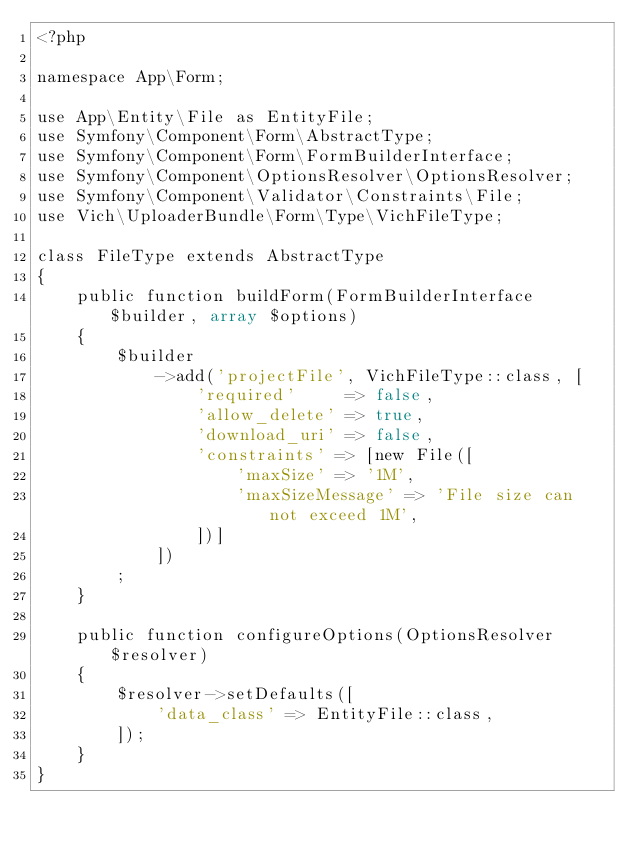Convert code to text. <code><loc_0><loc_0><loc_500><loc_500><_PHP_><?php

namespace App\Form;

use App\Entity\File as EntityFile;
use Symfony\Component\Form\AbstractType;
use Symfony\Component\Form\FormBuilderInterface;
use Symfony\Component\OptionsResolver\OptionsResolver;
use Symfony\Component\Validator\Constraints\File;
use Vich\UploaderBundle\Form\Type\VichFileType;

class FileType extends AbstractType
{
    public function buildForm(FormBuilderInterface $builder, array $options)
    {
        $builder
            ->add('projectFile', VichFileType::class, [
                'required'     => false,
                'allow_delete' => true,
                'download_uri' => false,
                'constraints' => [new File([
                    'maxSize' => '1M',
                    'maxSizeMessage' => 'File size can not exceed 1M',
                ])]
            ])
        ;
    }

    public function configureOptions(OptionsResolver $resolver)
    {
        $resolver->setDefaults([
            'data_class' => EntityFile::class,
        ]);
    }
}
</code> 